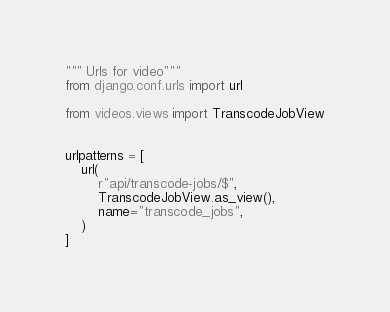<code> <loc_0><loc_0><loc_500><loc_500><_Python_>""" Urls for video"""
from django.conf.urls import url

from videos.views import TranscodeJobView


urlpatterns = [
    url(
        r"api/transcode-jobs/$",
        TranscodeJobView.as_view(),
        name="transcode_jobs",
    )
]
</code> 